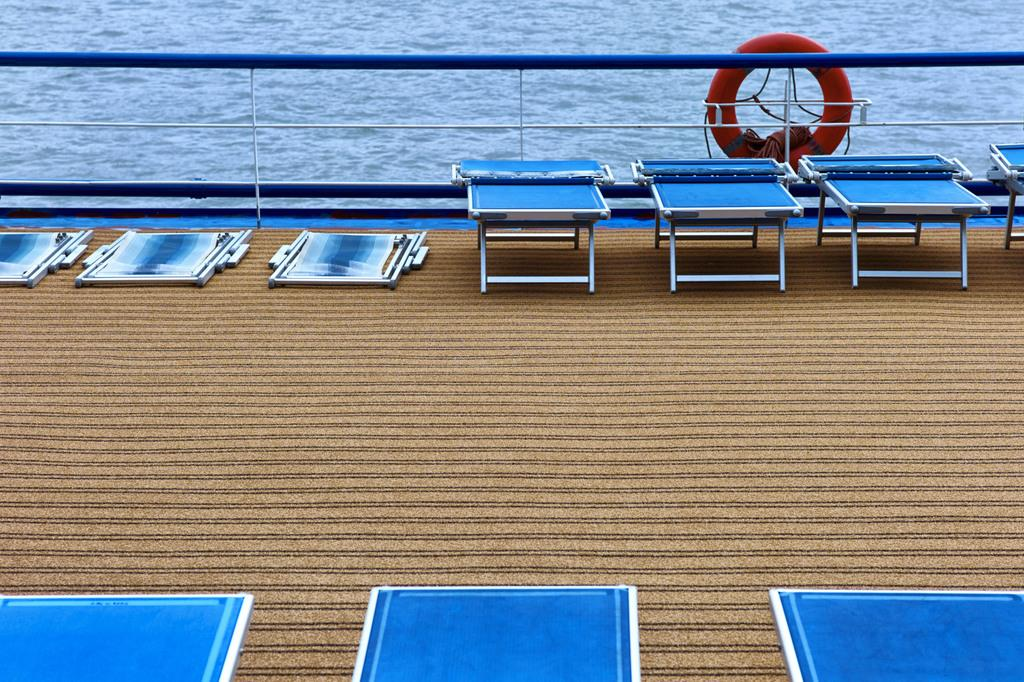What is the main object in the center of the image? There is a life savior in the center of the image. What type of structures can be seen in the image? There are fences in the image. What type of furniture is present in the image? There are tables in the image. What else can be seen in the image besides the life savior, fences, and tables? There are other objects in the image. What can be seen in the background of the image? There is water visible in the background of the image. What type of paper is being used to head the run in the image? There is no paper, running, or heading in the image; it features a life savior, fences, tables, and water in the background. 